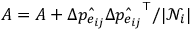<formula> <loc_0><loc_0><loc_500><loc_500>A = A + \Delta \hat { p _ { e _ { i j } } } \Delta \hat { p _ { e _ { i j } } } ^ { \top } / | \mathcal { N } _ { i } |</formula> 